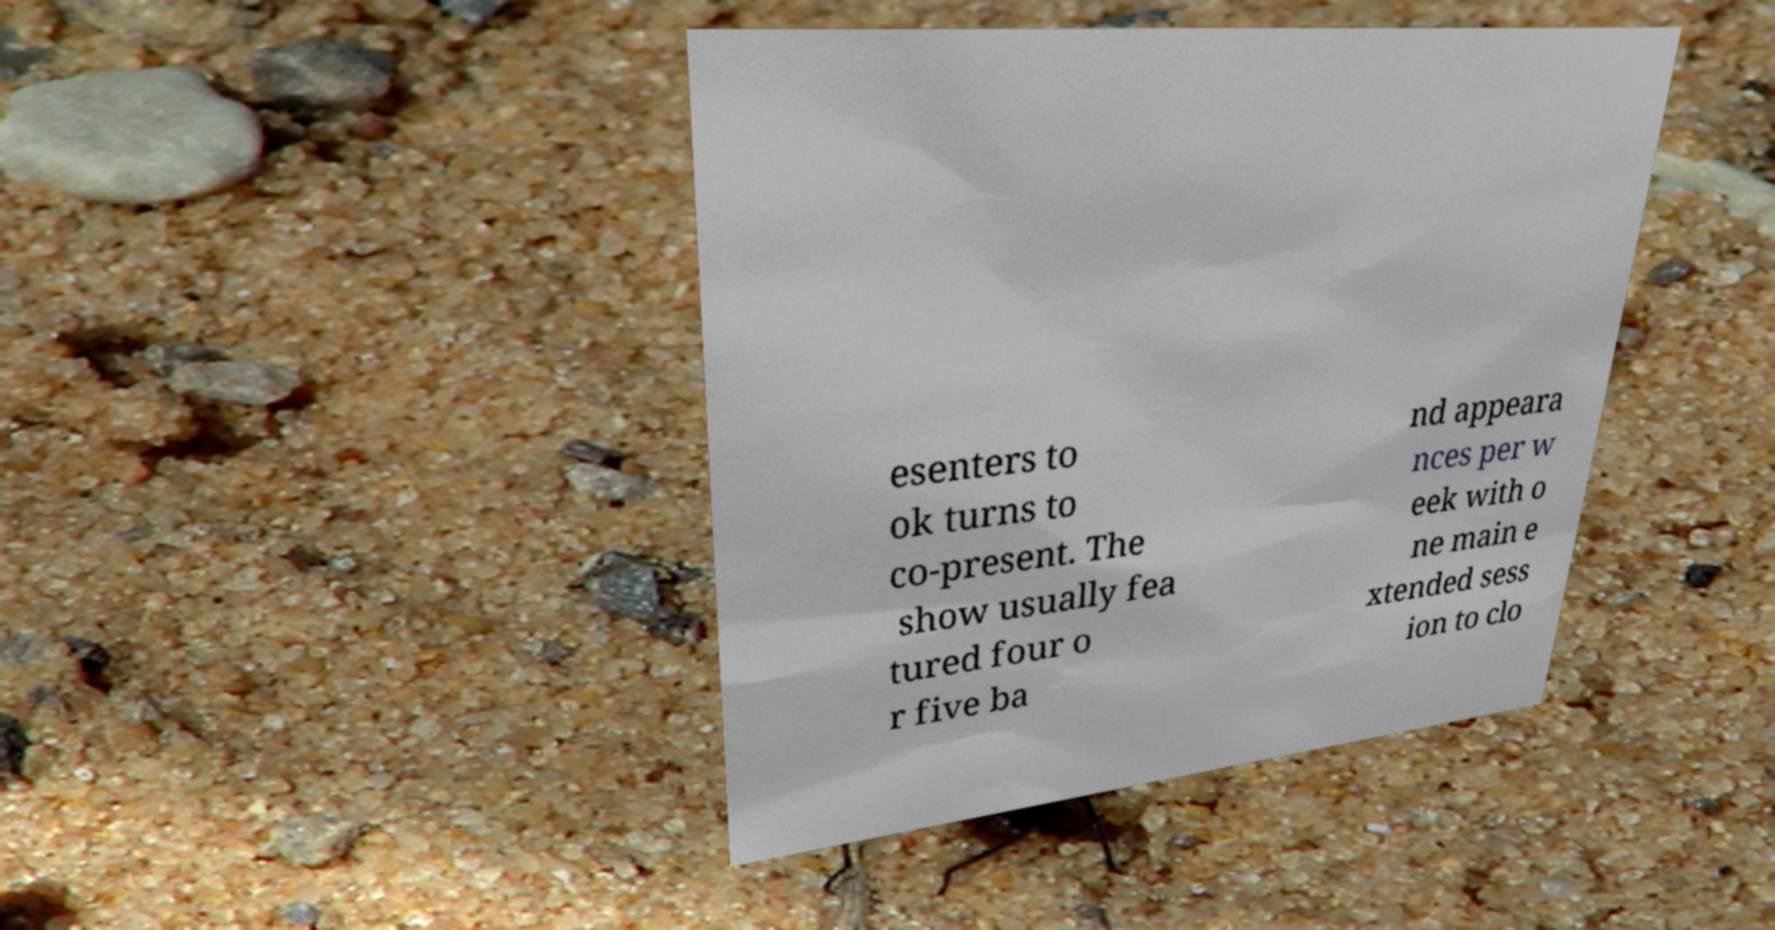Please read and relay the text visible in this image. What does it say? esenters to ok turns to co-present. The show usually fea tured four o r five ba nd appeara nces per w eek with o ne main e xtended sess ion to clo 